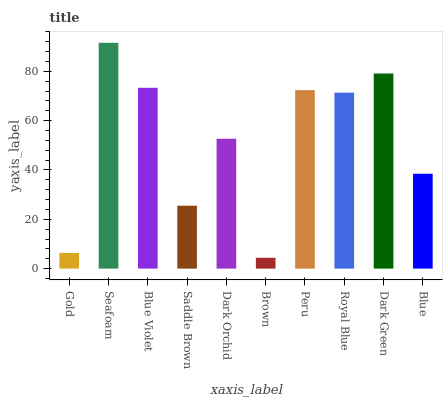Is Brown the minimum?
Answer yes or no. Yes. Is Seafoam the maximum?
Answer yes or no. Yes. Is Blue Violet the minimum?
Answer yes or no. No. Is Blue Violet the maximum?
Answer yes or no. No. Is Seafoam greater than Blue Violet?
Answer yes or no. Yes. Is Blue Violet less than Seafoam?
Answer yes or no. Yes. Is Blue Violet greater than Seafoam?
Answer yes or no. No. Is Seafoam less than Blue Violet?
Answer yes or no. No. Is Royal Blue the high median?
Answer yes or no. Yes. Is Dark Orchid the low median?
Answer yes or no. Yes. Is Seafoam the high median?
Answer yes or no. No. Is Peru the low median?
Answer yes or no. No. 